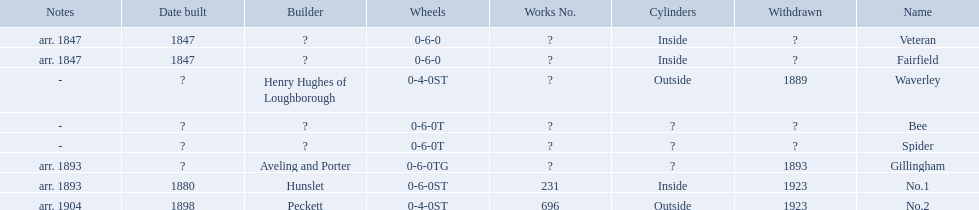What are the aldernay railways? Veteran, Fairfield, Waverley, Bee, Spider, Gillingham, No.1, No.2. Which ones were built in 1847? Veteran, Fairfield. Of those, which one is not fairfield? Veteran. 